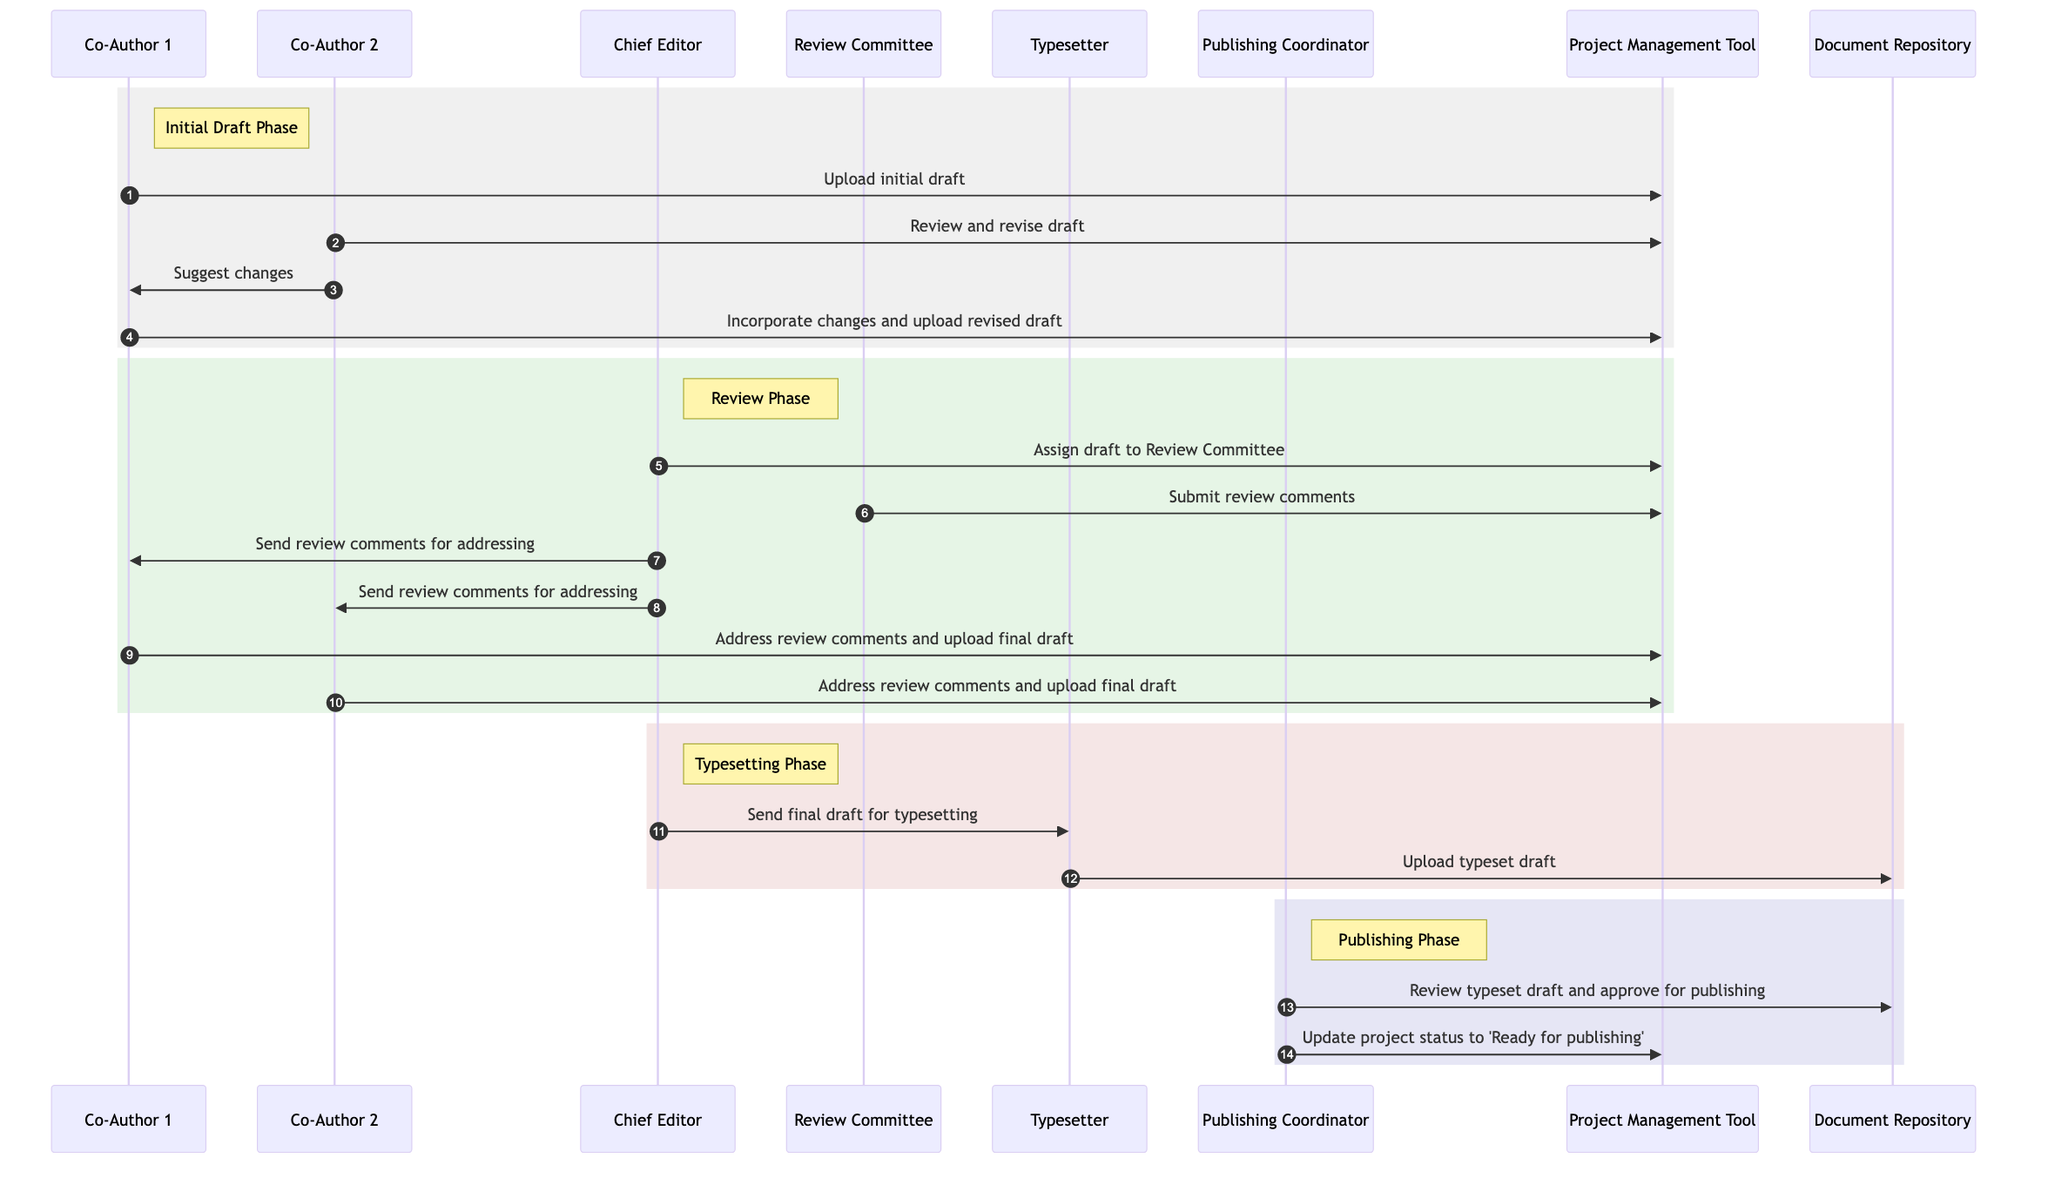What is the first action taken in the process? The first action is "Upload initial draft" which is performed by Co-Author 1 to the Project Management Tool. This sets the initiation of the collaborative writing process.
Answer: Upload initial draft Who reviews the draft after Co-Author 1 uploads the initial version? After Co-Author 1 uploads the draft, Co-Author 2 reviews and revises the draft in the Project Management Tool. This indicates the collaborative aspect of the writing phase.
Answer: Co-Author 2 How many participants are involved in the typesetting phase? There are two participants involved in the typesetting phase: the Chief Editor and the Typesetter. The Chief Editor sends the final draft to the Typesetter.
Answer: 2 What document is sent to the Typesetter? The document sent to the Typesetter is the "final draft." This indicates that the draft has undergone collaborative revisions and is ready for the typesetting process.
Answer: final draft Which tool is used for addressing review comments? The Project Management Tool is used for addressing review comments, as indicated by the actions taken by both Co-Authors after receiving comments from the Chief Editor.
Answer: Project Management Tool What does the Publishing Coordinator do last in the process? The last action taken by the Publishing Coordinator is to "Update project status to 'Ready for publishing'" in the Project Management Tool, which signifies the final step before the publication process.
Answer: Update project status to 'Ready for publishing' How many total interactions occur between Co-Authors and the Project Management Tool? There are four interactions between the Co-Authors and the Project Management Tool throughout the process, covering initial upload, revision, and final draft uploads.
Answer: 4 Which phase follows after the final draft is addressed by the Co-Authors? The phase that follows is the Typesetting Phase, where the Chief Editor sends the final draft to the Typesetter for typesetting, indicating progression in the publishing workflow.
Answer: Typesetting Phase What action is taken by the Review Committee? The action taken by the Review Committee is to "Submit review comments" in the Project Management Tool, which is crucial for improving the manuscript before finalization.
Answer: Submit review comments 